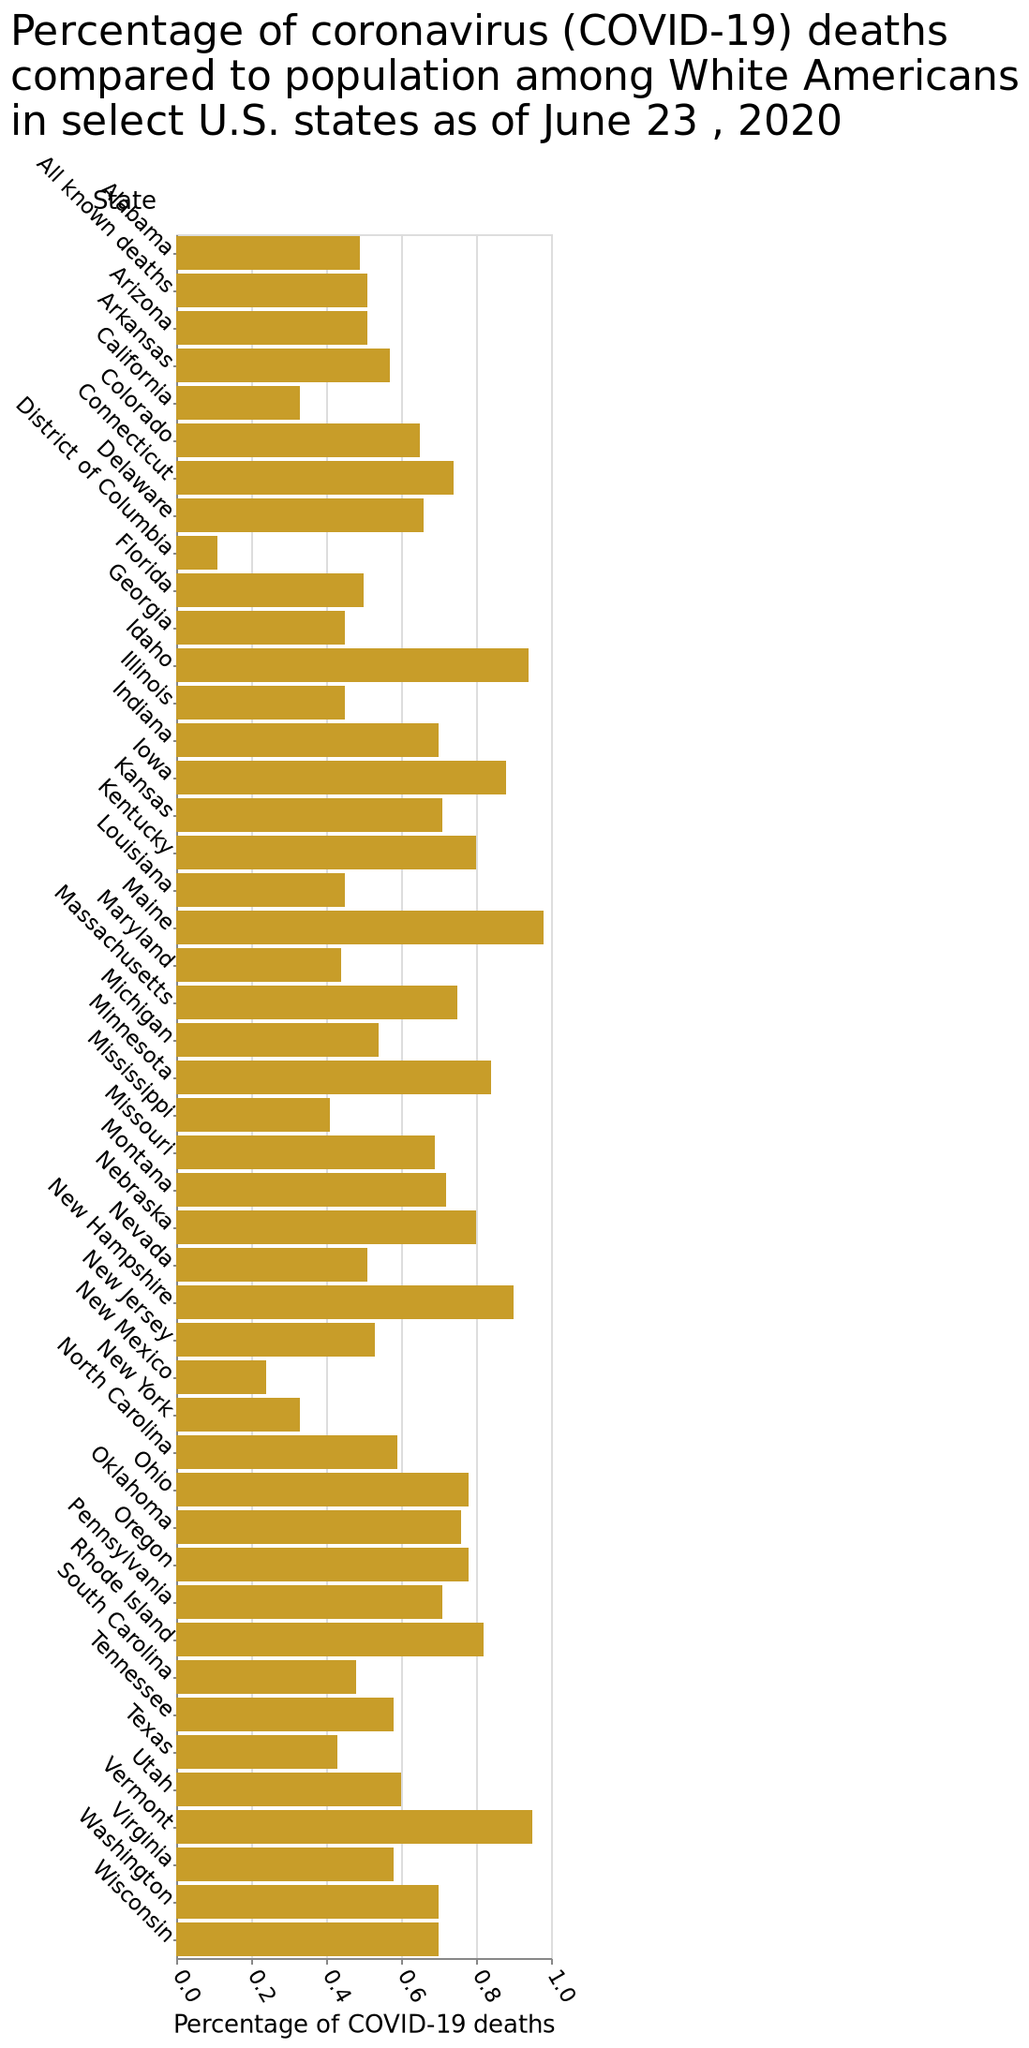<image>
How many states have a percentage of covid deaths above 0.8?  Only 7 states have a percentage of covid deaths above 0.8. What is the purpose of the linear scale on the x-axis? The purpose of the linear scale on the x-axis is to visually represent and compare the percentage of COVID-19 deaths among White Americans in different U.S. states. What does the y-axis represent in the bar plot? The y-axis represents the select U.S. states, measured using a categorical scale from Alabama to Wisconsin. 